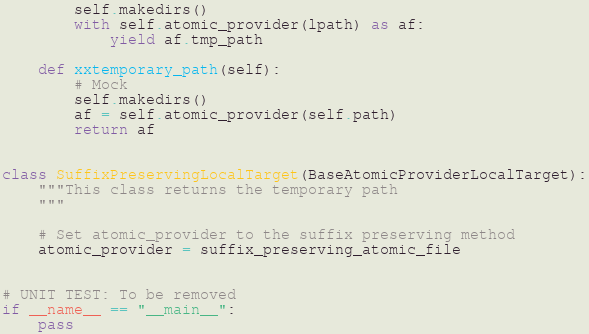<code> <loc_0><loc_0><loc_500><loc_500><_Python_>		self.makedirs()
		with self.atomic_provider(lpath) as af:
			yield af.tmp_path
	
	def xxtemporary_path(self):
		# Mock
		self.makedirs()
		af = self.atomic_provider(self.path) 
		return af


class SuffixPreservingLocalTarget(BaseAtomicProviderLocalTarget):
	"""This class returns the temporary path
	"""

	# Set atomic_provider to the suffix preserving method
	atomic_provider = suffix_preserving_atomic_file


# UNIT TEST: To be removed
if __name__ == "__main__": 
	pass</code> 